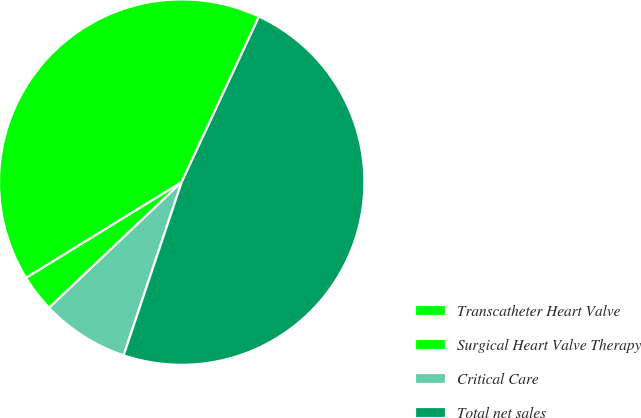<chart> <loc_0><loc_0><loc_500><loc_500><pie_chart><fcel>Transcatheter Heart Valve<fcel>Surgical Heart Valve Therapy<fcel>Critical Care<fcel>Total net sales<nl><fcel>40.74%<fcel>3.29%<fcel>7.78%<fcel>48.19%<nl></chart> 